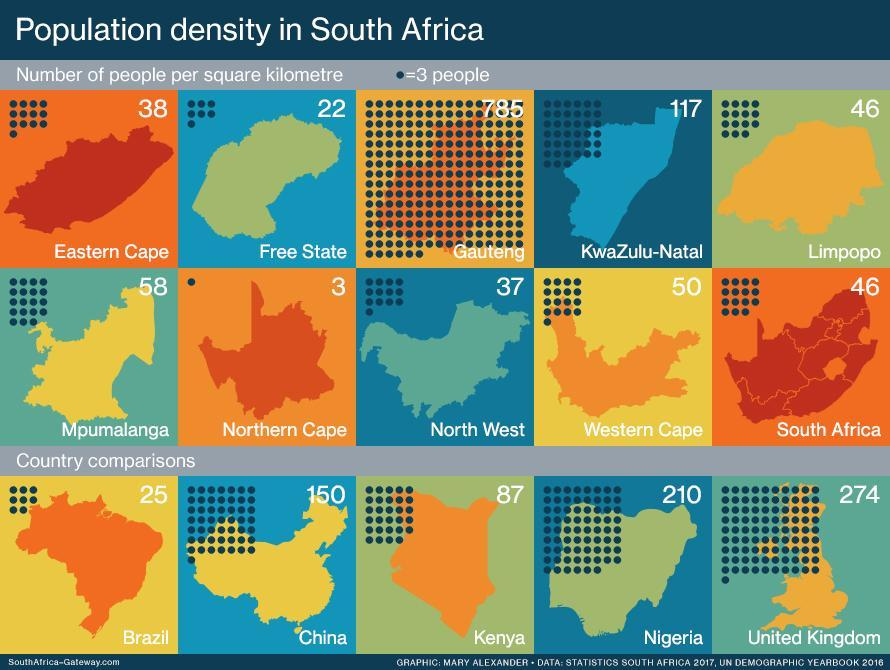Which province of South Africa is least densely populated?
Answer the question with a short phrase. Northern Cape Which province of South Africa is most densely populated? Gauteng Which country is the most densely populated? United Kingdom Which country is the least densely populated? Brazil 